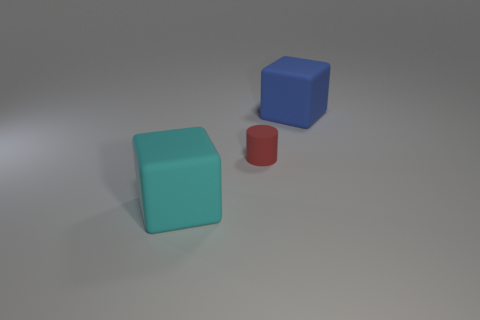Add 3 tiny red cubes. How many objects exist? 6 Subtract all blocks. How many objects are left? 1 Add 1 blue objects. How many blue objects are left? 2 Add 3 small red shiny cylinders. How many small red shiny cylinders exist? 3 Subtract 0 brown blocks. How many objects are left? 3 Subtract all green blocks. Subtract all large objects. How many objects are left? 1 